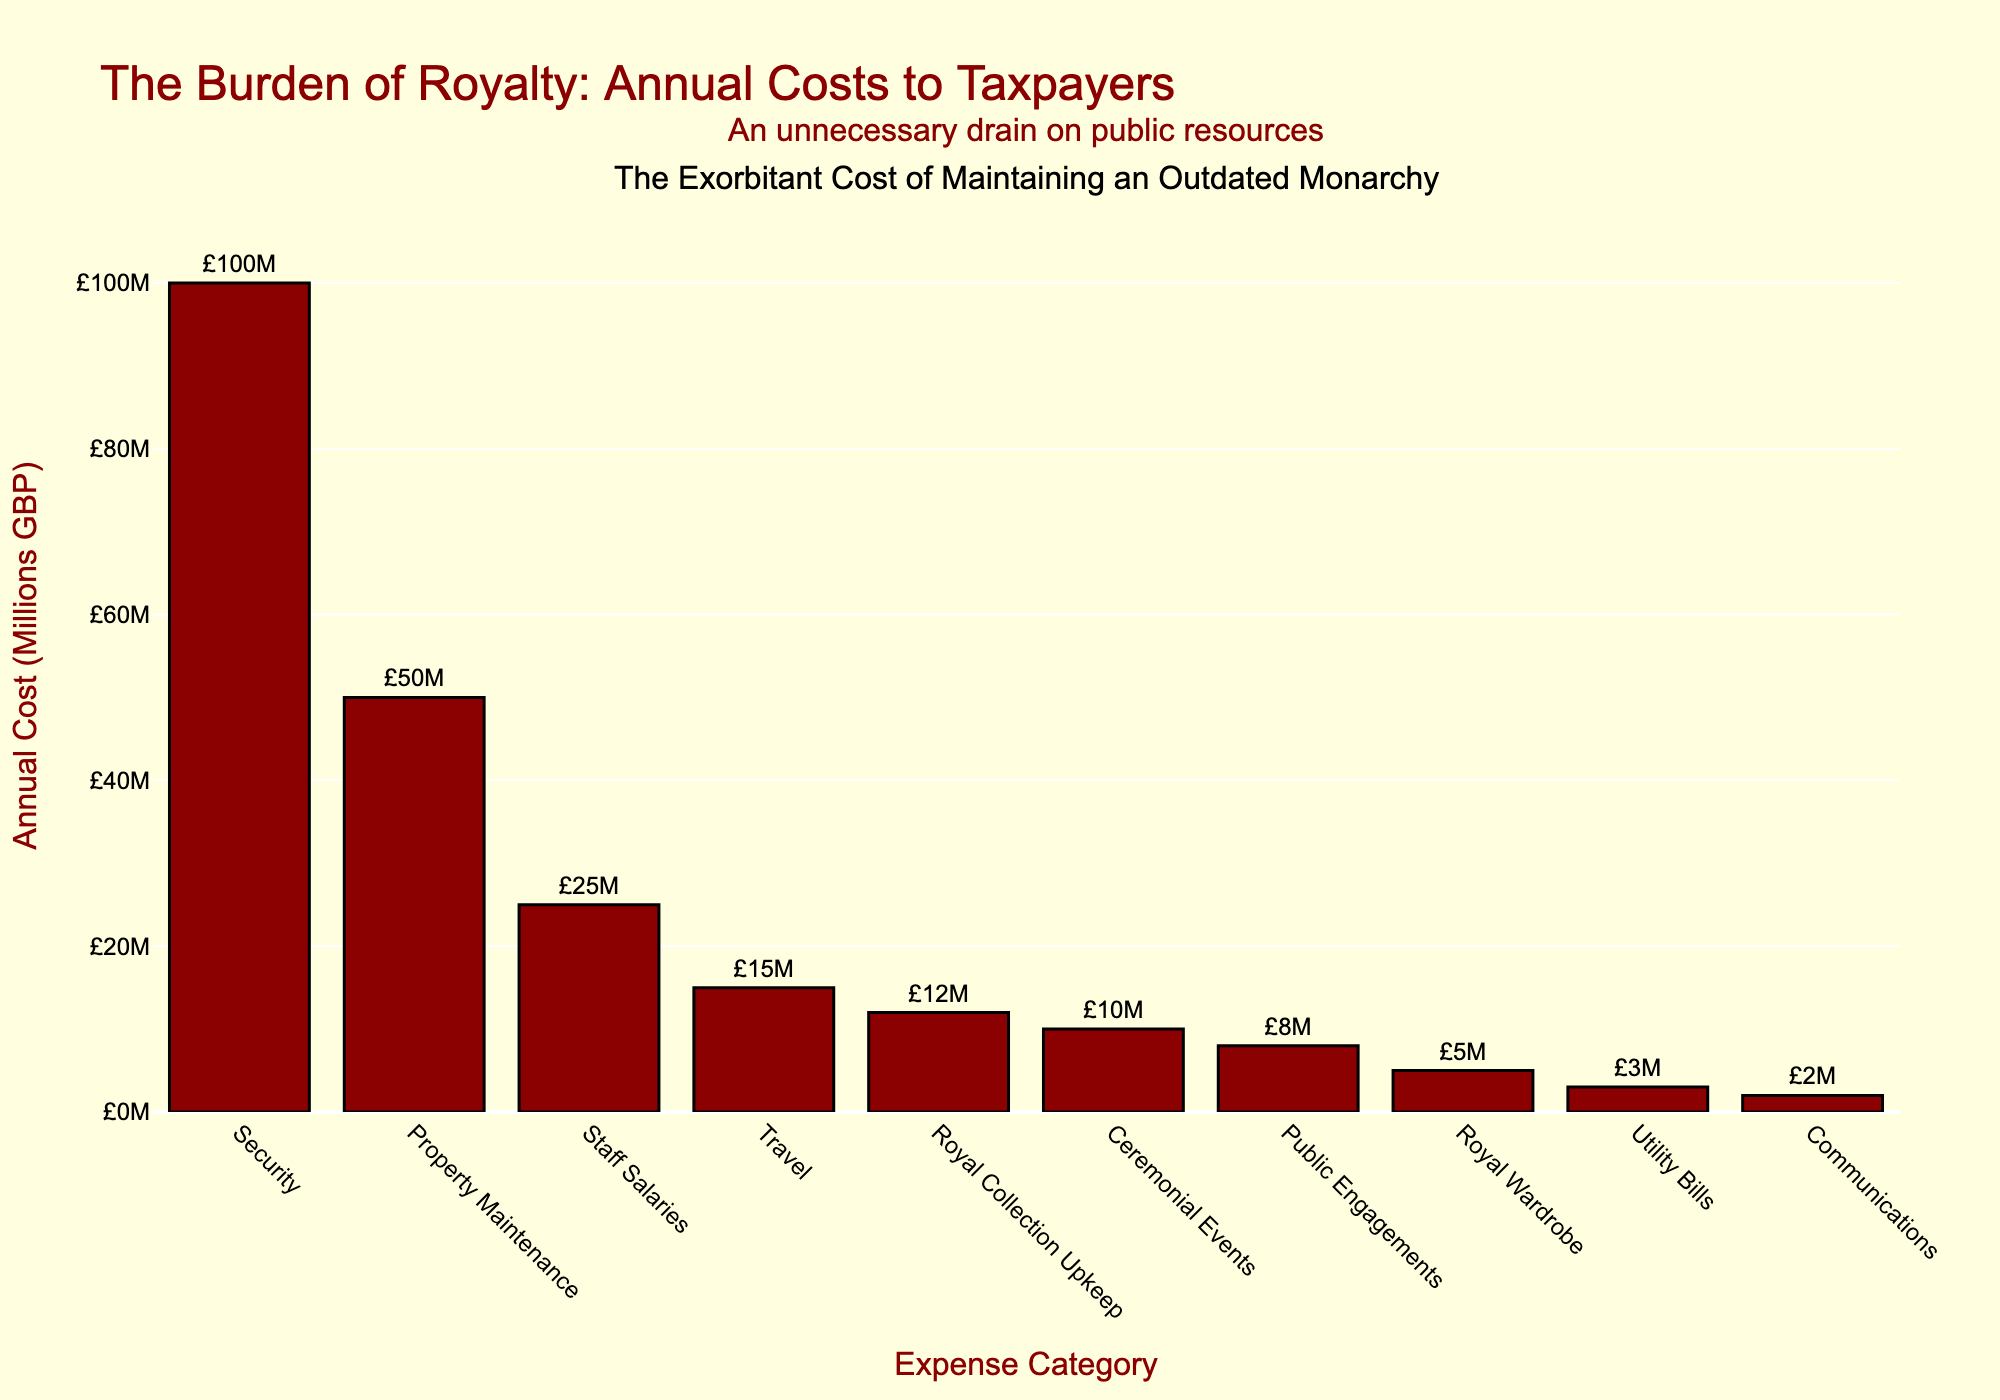What is the title of the plot? The title of the plot is located at the top of the figure, written in a larger and bold font to attract attention. The title is "The Burden of Royalty: Annual Costs to Taxpayers."
Answer: "The Burden of Royalty: Annual Costs to Taxpayers" How much is spent annually on Security for the royal family? By looking at the tallest bar on the histogram, labeled "Security" at the top of the y-axis and the text annotation, you can see that £100M is spent annually on Security.
Answer: £100M Which expense category has the smallest annual cost, and what is that cost? By identifying the shortest bar at the rightmost part of the histogram, labeled "Communications," and the text annotation above it, you can see that Communications has the smallest annual cost of £2M.
Answer: Communications, £2M What are the annual costs associated with Property Maintenance, Travel, and Royal Wardrobe, summed together? Find the bar heights of Property Maintenance (50M), Travel (15M), and Royal Wardrobe (5M), then sum these values: 50 + 15 + 5 = 70. So, the annual costs together equal £70M.
Answer: £70M What is the difference between the annual costs for Staff Salaries and Royal Collection Upkeep? Locate the bars for Staff Salaries (25M) and Royal Collection Upkeep (12M), then calculate the difference: 25 - 12 = 13. The difference is £13M.
Answer: £13M Which expense category costs more, Ceremonial Events or Public Engagements? By comparing the heights of the bars labeled "Ceremonial Events" (10M) and "Public Engagements" (8M), you can see that Ceremonial Events costs more.
Answer: Ceremonial Events What fraction of the total annual costs is spent on Utility Bills? Identify the total annual cost by summing all expenses: 100+15+50+25+10+5+8+3+12+2 = 230. Then, locate Utility Bills at 3M and calculate the fraction: 3/230 ≈ 1.30%. So, about 1.30% of the total annual costs are spent on Utility Bills.
Answer: 1.30% What is the combined annual cost for Security and Property Maintenance? Find the bar heights for Security (100M) and Property Maintenance (50M) and add them together: 100 + 50 = 150. The combined annual cost is £150M.
Answer: £150M If the budget for Security were cut by 50%, how would it compare to the current cost of Property Maintenance? Security costs £100M. If reduced by 50%, it would be 100/2 = 50M, making it equal to the current cost of Property Maintenance (50M).
Answer: Equal to Property Maintenance 